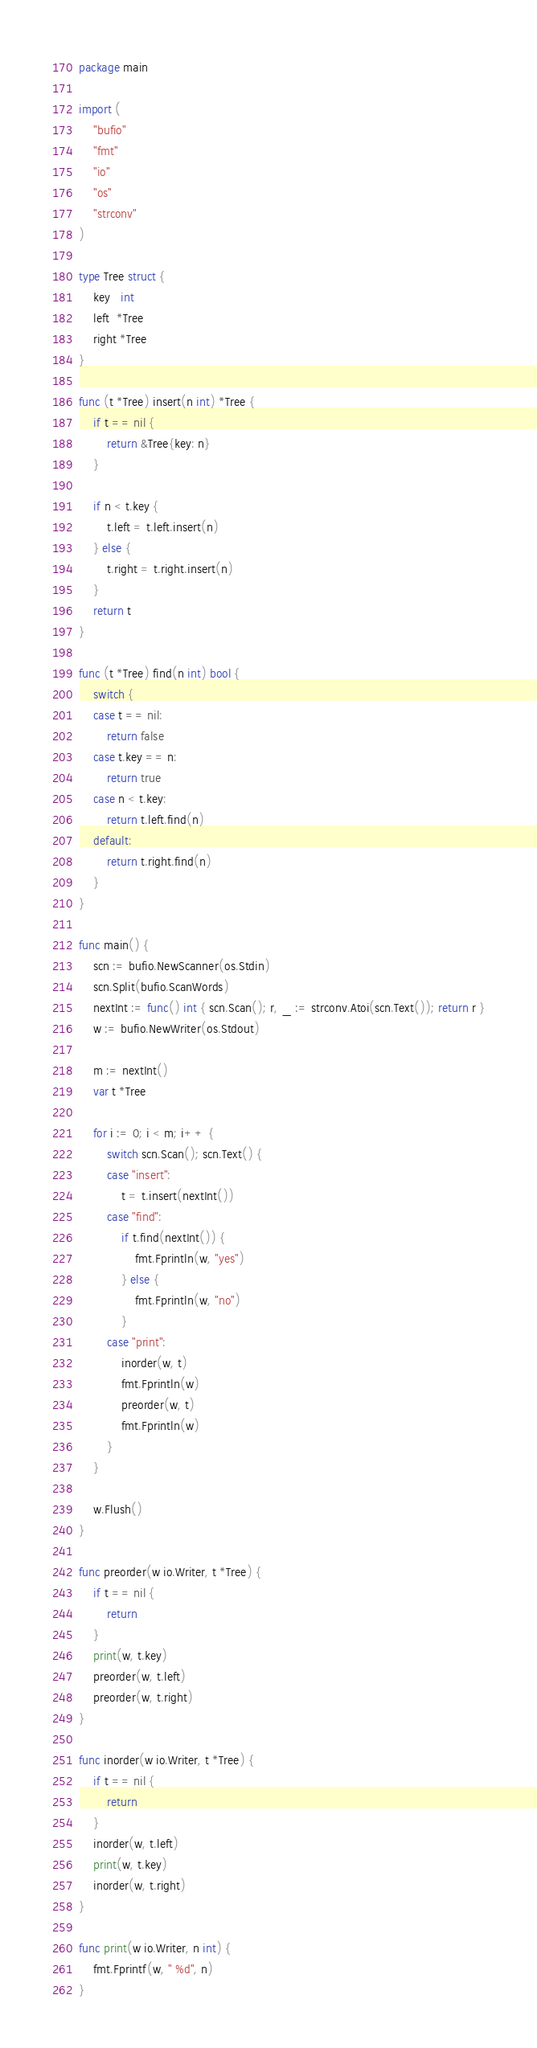<code> <loc_0><loc_0><loc_500><loc_500><_Go_>package main

import (
	"bufio"
	"fmt"
	"io"
	"os"
	"strconv"
)

type Tree struct {
	key   int
	left  *Tree
	right *Tree
}

func (t *Tree) insert(n int) *Tree {
	if t == nil {
		return &Tree{key: n}
	}

	if n < t.key {
		t.left = t.left.insert(n)
	} else {
		t.right = t.right.insert(n)
	}
	return t
}

func (t *Tree) find(n int) bool {
	switch {
	case t == nil:
		return false
	case t.key == n:
		return true
	case n < t.key:
		return t.left.find(n)
	default:
		return t.right.find(n)
	}
}

func main() {
	scn := bufio.NewScanner(os.Stdin)
	scn.Split(bufio.ScanWords)
	nextInt := func() int { scn.Scan(); r, _ := strconv.Atoi(scn.Text()); return r }
	w := bufio.NewWriter(os.Stdout)

	m := nextInt()
	var t *Tree

	for i := 0; i < m; i++ {
		switch scn.Scan(); scn.Text() {
		case "insert":
			t = t.insert(nextInt())
		case "find":
			if t.find(nextInt()) {
				fmt.Fprintln(w, "yes")
			} else {
				fmt.Fprintln(w, "no")
			}
		case "print":
			inorder(w, t)
			fmt.Fprintln(w)
			preorder(w, t)
			fmt.Fprintln(w)
		}
	}

	w.Flush()
}

func preorder(w io.Writer, t *Tree) {
	if t == nil {
		return
	}
	print(w, t.key)
	preorder(w, t.left)
	preorder(w, t.right)
}

func inorder(w io.Writer, t *Tree) {
	if t == nil {
		return
	}
	inorder(w, t.left)
	print(w, t.key)
	inorder(w, t.right)
}

func print(w io.Writer, n int) {
	fmt.Fprintf(w, " %d", n)
}

</code> 